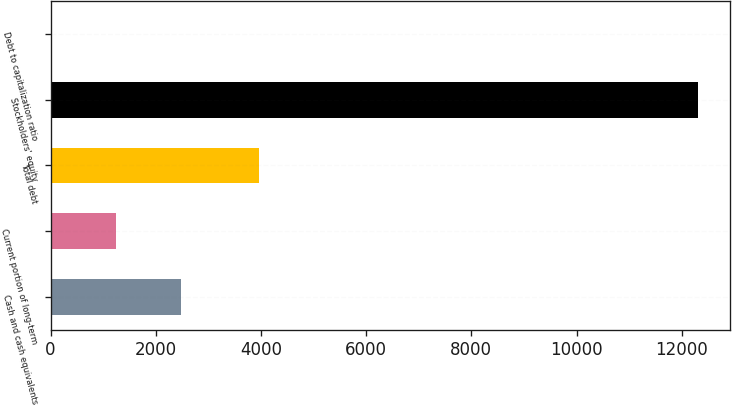<chart> <loc_0><loc_0><loc_500><loc_500><bar_chart><fcel>Cash and cash equivalents<fcel>Current portion of long-term<fcel>Total debt<fcel>Stockholders' equity<fcel>Debt to capitalization ratio<nl><fcel>2480.84<fcel>1252.57<fcel>3955<fcel>12307<fcel>24.3<nl></chart> 